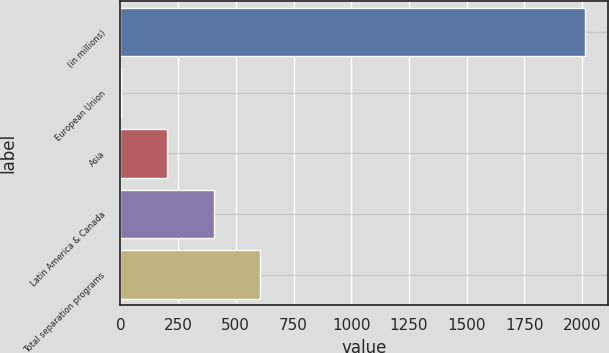<chart> <loc_0><loc_0><loc_500><loc_500><bar_chart><fcel>(in millions)<fcel>European Union<fcel>Asia<fcel>Latin America & Canada<fcel>Total separation programs<nl><fcel>2012<fcel>3<fcel>203.9<fcel>404.8<fcel>605.7<nl></chart> 